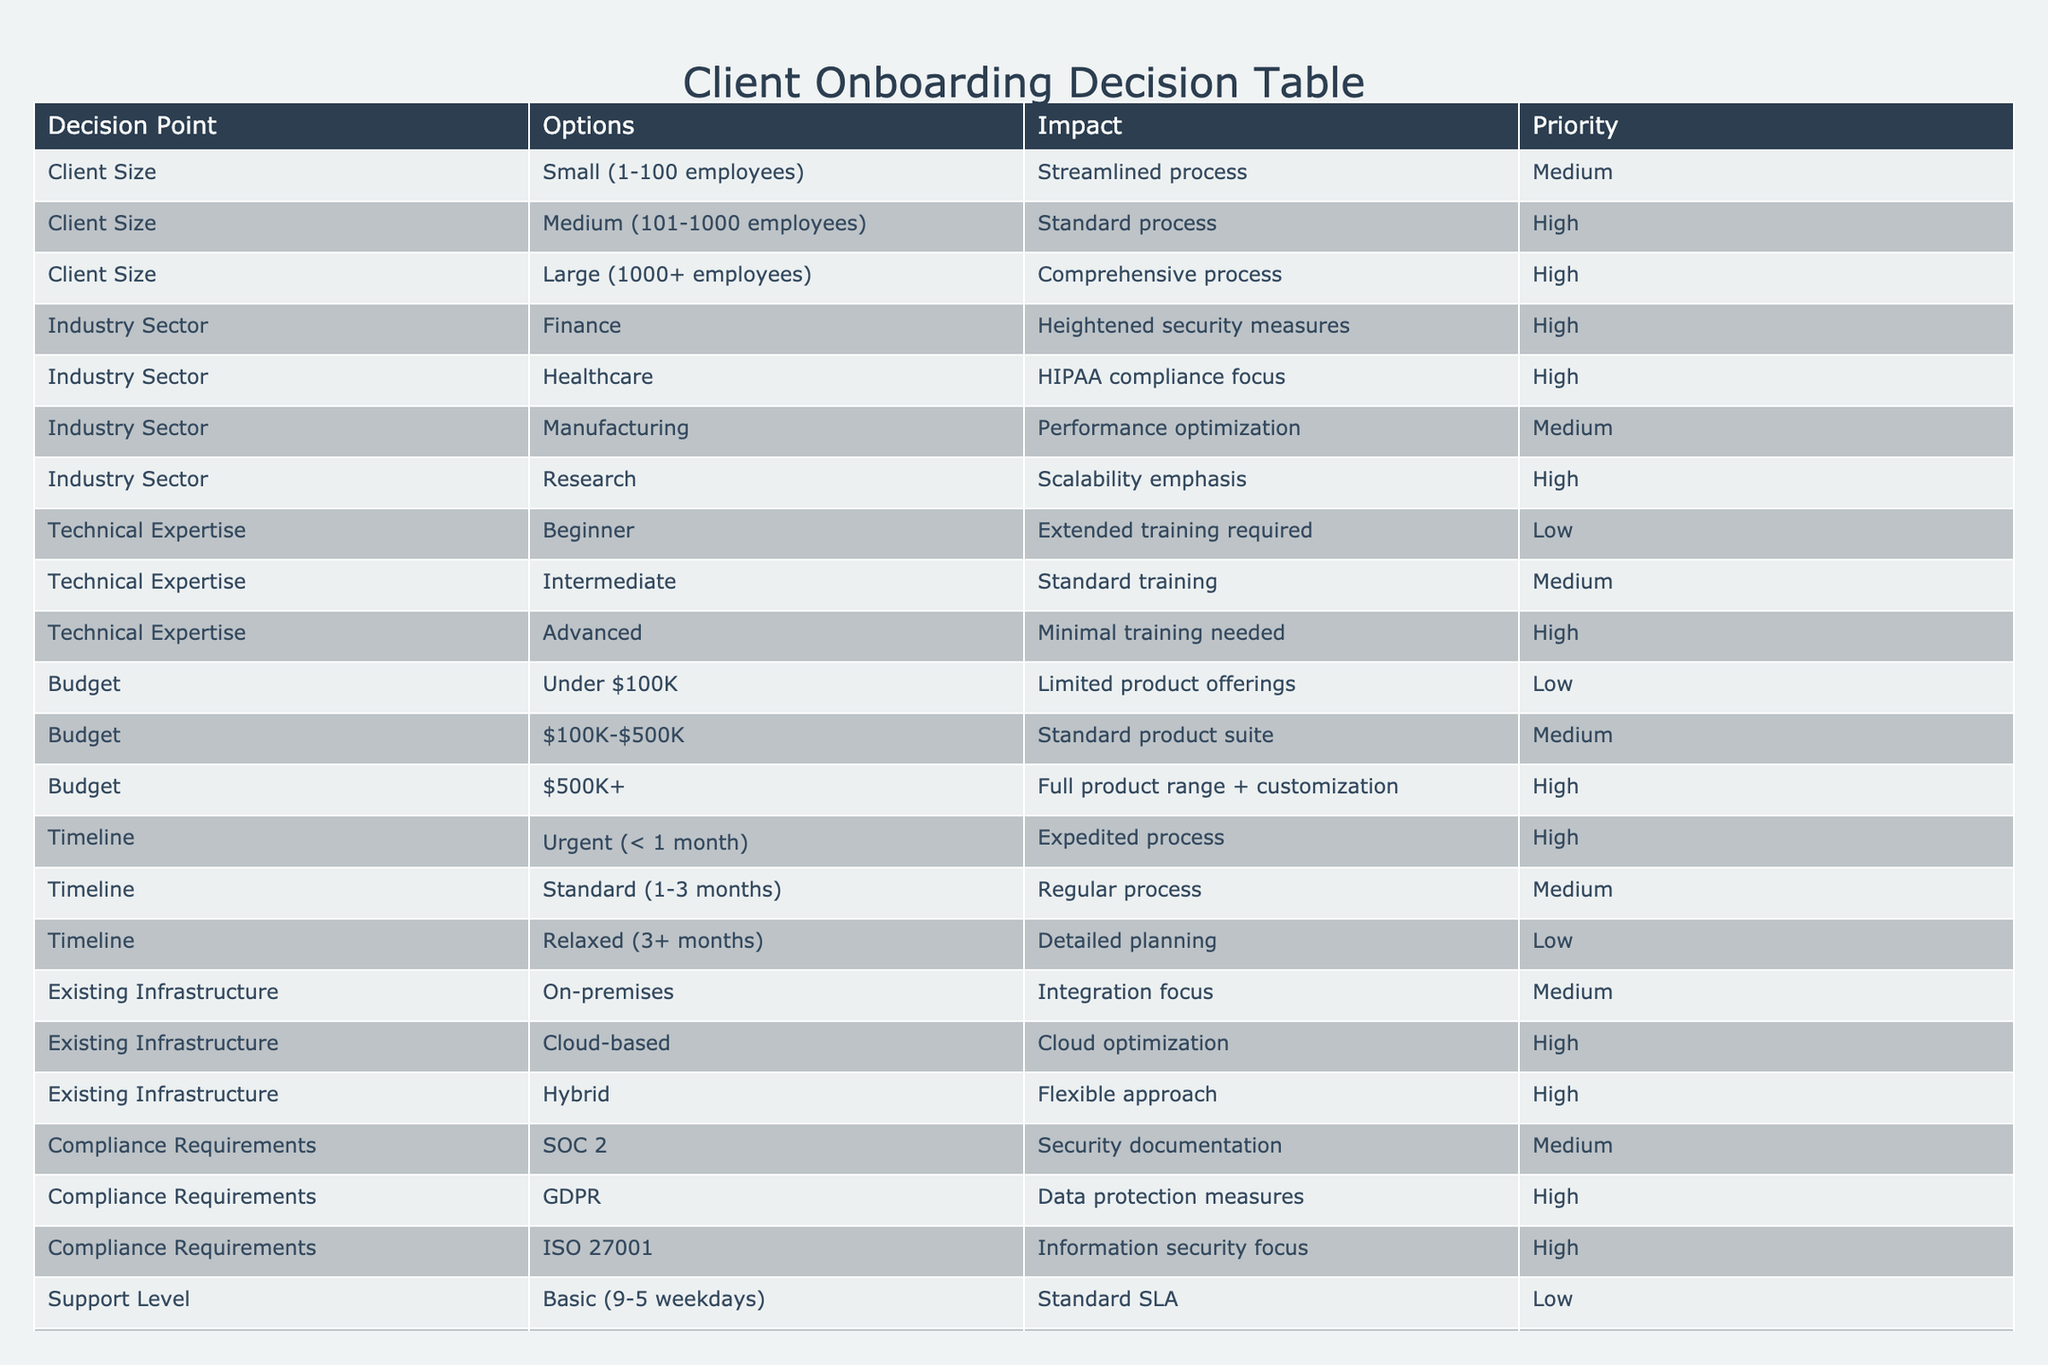What is the impact of a large client size? According to the table, a large client size (1000+ employees) leads to a comprehensive onboarding process, which is listed under the impact column.
Answer: Comprehensive process Which industry sector has the highest priority for onboarding? The sectors that have the highest priority according to the table are Finance, Healthcare, Research, and GDPR under Compliance Requirements. All these options are classified as high priorities.
Answer: Finance, Healthcare, Research, GDPR If a client has a budget of over 500K, what impact can they expect? The table specifies that a budget of over 500K allows clients access to the full product range along with customization, categorized under high impact.
Answer: Full product range + customization Is an urgent timeline considered a high priority? Yes, the table indicates that an urgent timeline of less than 1 month is associated with an expedited onboarding process, which is classified as high priority.
Answer: Yes What is the average priority rating for the client size category? The client size category has three options: small (medium), medium (high), and large (high). Converting these to numerical values: medium = 2, high = 3. Therefore, the average rating is (2 + 3 + 3) / 3 = 2.67, which is approximately 2.7 when rounded.
Answer: 2.7 In which scenarios would a client require extended training? Based on the table, clients defined as beginners in technical expertise need extended training, which is categorized as low impact. The explanation requires identifying both the level of expertise and training needs accordingly.
Answer: Beginner Does having a cloud-based existing infrastructure offer high support levels? True, the table shows that a cloud-based existing infrastructure correlates with high priority for optimization but does not directly relate to support level; thus, this is a nuanced question. The external support level would depend on another factor altogether.
Answer: False What are the compliance requirements for GDPR, and what is the associated impact? GDPR compliance requirements focus on data protection measures, and based on the table, it is classified as a high impact area, thus it necessitates specific focus for it during onboarding.
Answer: Data protection measures, high impact What options are available for clients with intermediate technical expertise? The table indicates that clients with intermediate technical expertise will receive standard training, and the impact is categorized as medium. It combines the category with its corresponding impact classification to provide clarity.
Answer: Standard training, medium impact 